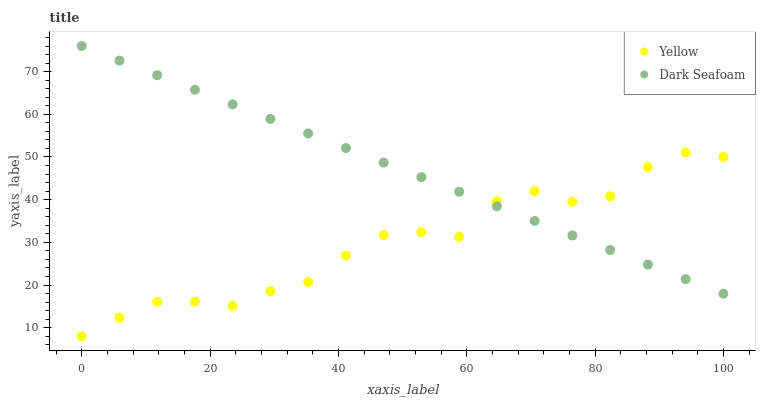Does Yellow have the minimum area under the curve?
Answer yes or no. Yes. Does Dark Seafoam have the maximum area under the curve?
Answer yes or no. Yes. Does Yellow have the maximum area under the curve?
Answer yes or no. No. Is Dark Seafoam the smoothest?
Answer yes or no. Yes. Is Yellow the roughest?
Answer yes or no. Yes. Is Yellow the smoothest?
Answer yes or no. No. Does Yellow have the lowest value?
Answer yes or no. Yes. Does Dark Seafoam have the highest value?
Answer yes or no. Yes. Does Yellow have the highest value?
Answer yes or no. No. Does Yellow intersect Dark Seafoam?
Answer yes or no. Yes. Is Yellow less than Dark Seafoam?
Answer yes or no. No. Is Yellow greater than Dark Seafoam?
Answer yes or no. No. 